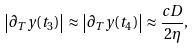Convert formula to latex. <formula><loc_0><loc_0><loc_500><loc_500>\left | \partial _ { T } y ( t _ { 3 } ) \right | \approx \left | \partial _ { T } y ( t _ { 4 } ) \right | \approx \frac { c D } { 2 \eta } ,</formula> 